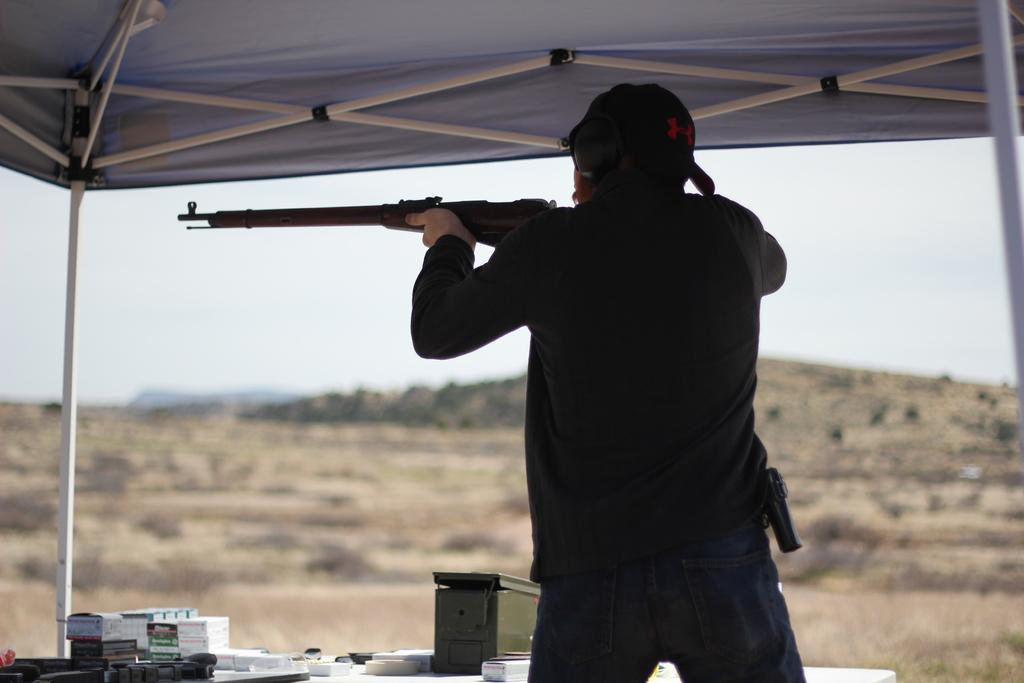What is the main subject of the image? There is a person in the image. What is the person holding in their hand? The person is holding a gun in their hand. What can be seen on the table in the image? There are boxes and other objects on a table. Can you describe the background of the image? The background of the image is blurry. Where is the nest located in the image? There is no nest present in the image. Can you describe the volcano in the image? There is no volcano present in the image. 